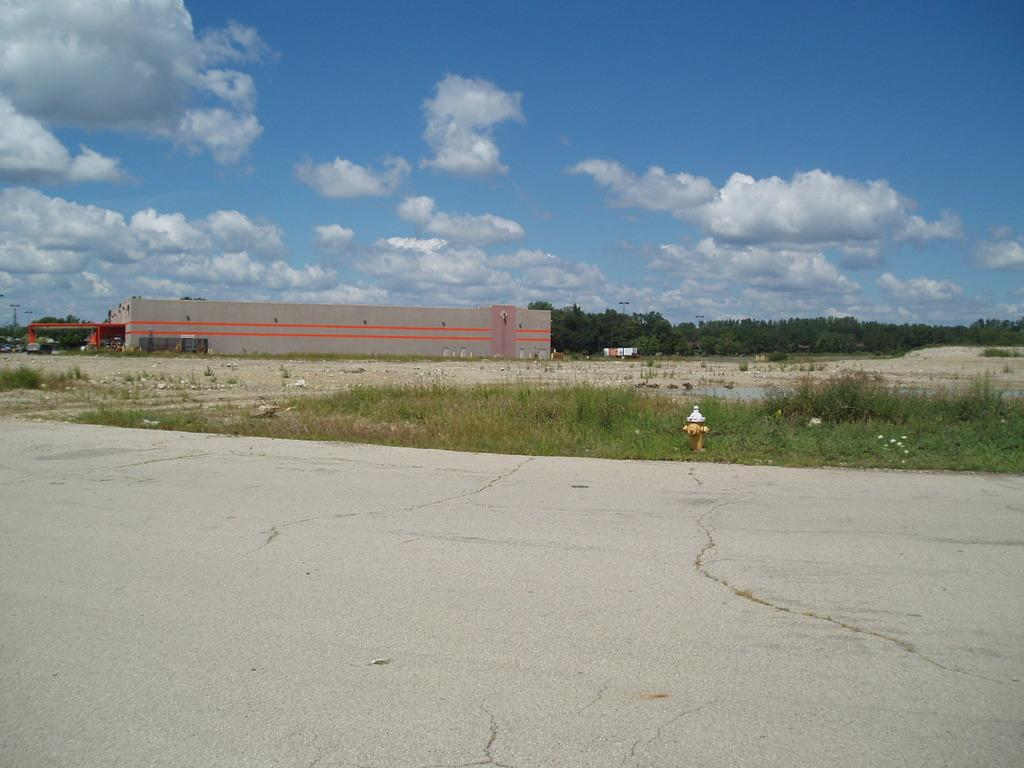What is there is a road in the image, what else can be seen? In addition to the road, there is a building, grass, plants, trees, vehicles, and the sky visible in the image. Can you describe the type of vegetation present in the image? Yes, there are plants and trees visible in the image. What is the condition of the sky in the image? The sky is visible in the image, and there are clouds present. What type of structures can be seen in the image? There is a building visible in the image. Can you tell me where the toothbrush is located in the image? There is no toothbrush present in the image. What example of a quiet place can be seen in the image? The image does not depict a quiet place, as there are vehicles and a road visible. 